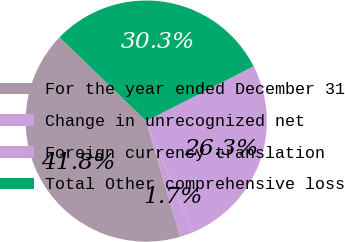<chart> <loc_0><loc_0><loc_500><loc_500><pie_chart><fcel>For the year ended December 31<fcel>Change in unrecognized net<fcel>Foreign currency translation<fcel>Total Other comprehensive loss<nl><fcel>41.77%<fcel>1.7%<fcel>26.26%<fcel>30.27%<nl></chart> 